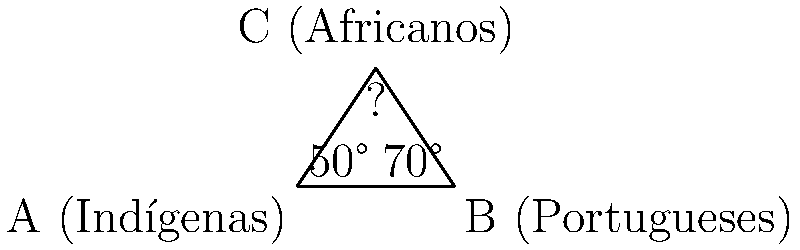Em um triângulo representando os três principais grupos étnicos na formação da identidade brasileira, os ângulos internos simbolizam a influência de cada grupo. Se o ângulo correspondente aos indígenas é 50° e o dos portugueses é 70°, qual é o ângulo que representa a influência africana na formação da identidade nacional brasileira? Para resolver esta questão, vamos seguir os seguintes passos:

1. Recordemos que a soma dos ângulos internos de um triângulo é sempre 180°.

2. Temos dois ângulos conhecidos:
   - Indígenas: 50°
   - Portugueses: 70°

3. Vamos chamar o ângulo desconhecido (africanos) de $x$.

4. Podemos estabelecer a equação:
   $50° + 70° + x = 180°$

5. Simplificando:
   $120° + x = 180°$

6. Subtraindo 120° de ambos os lados:
   $x = 180° - 120°$

7. Resolvendo:
   $x = 60°$

Portanto, o ângulo que representa a influência africana é 60°.
Answer: 60° 